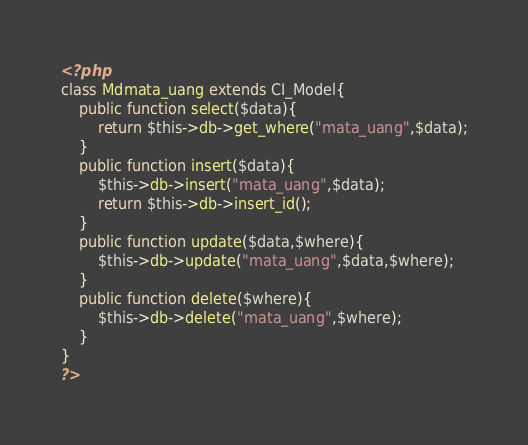Convert code to text. <code><loc_0><loc_0><loc_500><loc_500><_PHP_><?php
class Mdmata_uang extends CI_Model{
    public function select($data){
        return $this->db->get_where("mata_uang",$data);
    }
    public function insert($data){
        $this->db->insert("mata_uang",$data);
        return $this->db->insert_id();
    }
    public function update($data,$where){
        $this->db->update("mata_uang",$data,$where);
    }
    public function delete($where){
        $this->db->delete("mata_uang",$where);
    }
}
?></code> 